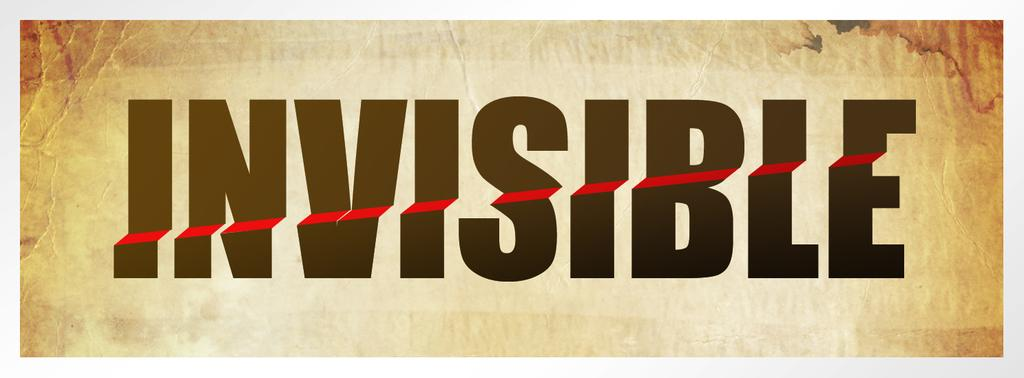<image>
Offer a succinct explanation of the picture presented. A sign says "invisible" in 3-D style font. 